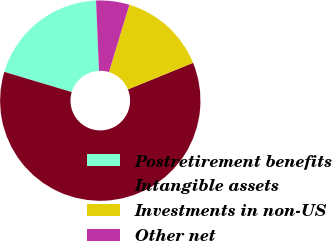Convert chart to OTSL. <chart><loc_0><loc_0><loc_500><loc_500><pie_chart><fcel>Postretirement benefits<fcel>Intangible assets<fcel>Investments in non-US<fcel>Other net<nl><fcel>19.7%<fcel>60.78%<fcel>14.16%<fcel>5.36%<nl></chart> 